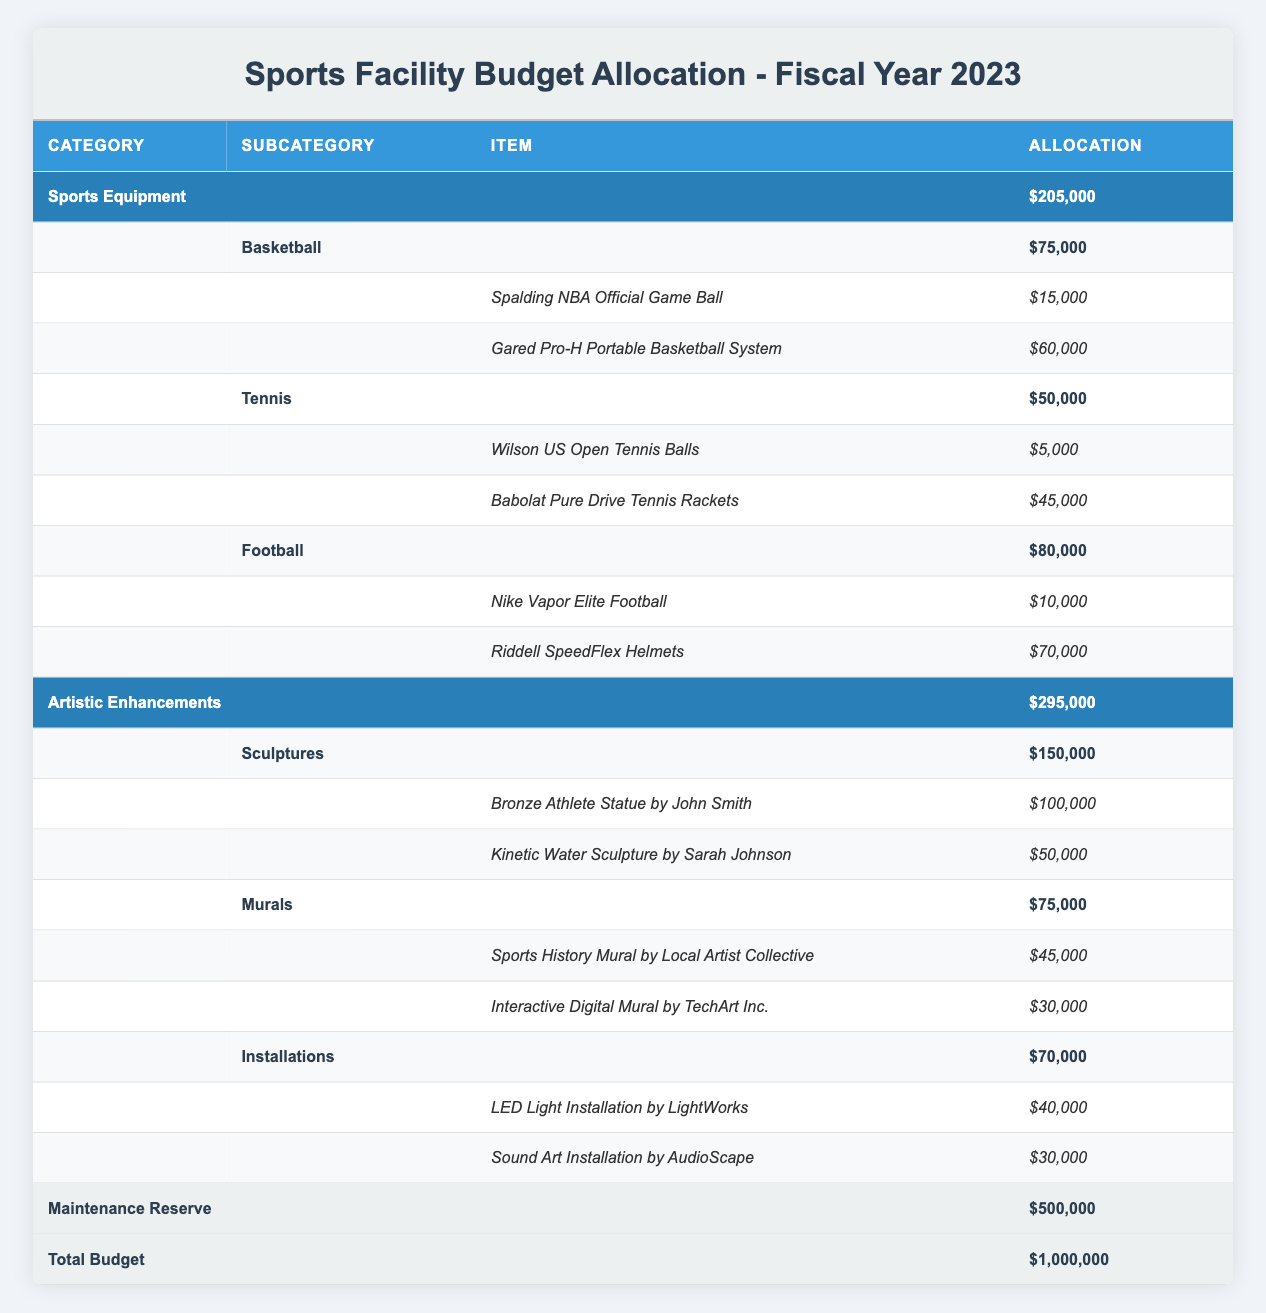What is the total allocation for Sports Equipment? The total allocation for Sports Equipment can be found in the category row labeled "Sports Equipment" which indicates an allocation of $205,000.
Answer: 205000 What is the allocation for the Kinetic Water Sculpture by Sarah Johnson? The allocation for the Kinetic Water Sculpture by Sarah Johnson is explicitly listed in the table under the Sculptures subcategory, which amounts to $50,000.
Answer: 50000 How much more is spent on Sculptures compared to Tennis Equipment? The total allocation for Sculptures is $150,000, and for Tennis Equipment, it's $50,000. To find the difference, we subtract the Tennis allocation from the Sculptures allocation: $150,000 - $50,000 = $100,000.
Answer: 100000 Is the total budget for Artistic Enhancements greater than that for Sports Equipment? The total budget for Artistic Enhancements is $295,000, while Sports Equipment is $205,000. Since 295,000 is greater than 205,000, the statement is true.
Answer: True What is the average allocation for the items under Football Equipment? The allocation for Football Equipment is $80,000, with 2 items listed. To find the average, we divide the total allocation by the number of items: $80,000 / 2 = $40,000.
Answer: 40000 What is the total allocation for Interactive Digital Murals? The allocation for Interactive Digital Murals is $30,000, as indicated in the Mural subcategory in the table.
Answer: 30000 How much is allocated for Installations compared to the total maintenance reserve? The total allocation for Installations is $70,000, while the maintenance reserve is $500,000. The comparison shows that the maintenance reserve is much larger than the Installations allocation.
Answer: 70,000 How much do the Riddell SpeedFlex Helmets cost? The cost for Riddell SpeedFlex Helmets is found under the Football subcategory, amounting to $70,000 as explicitly listed in the item row.
Answer: 70000 What is the combined total allocation for Artistic Enhancements and Sports Equipment? The total allocation for Artistic Enhancements is $295,000 and for Sports Equipment is $205,000. To find the combined total, we add these two figures: $295,000 + $205,000 = $500,000.
Answer: 500000 